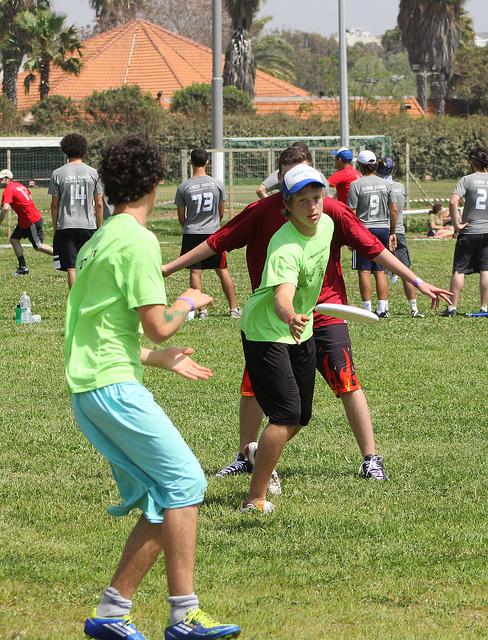What are the people doing?
Concise answer only. Playing frisbee. What are they throwing?
Be succinct. Frisbee. What is that large orange object?
Keep it brief. Roof. Is there multiple games being played here?
Quick response, please. Yes. Who is in the background?
Short answer required. Boys. 